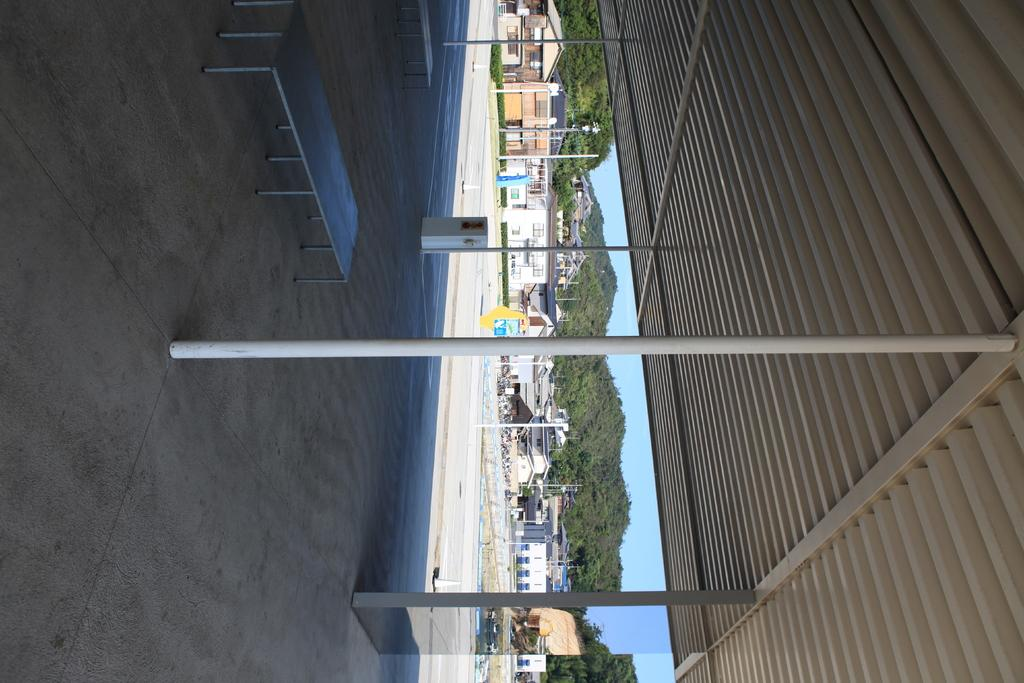What structure is located on the right side of the image? There is a shed on the right side of the image. What can be seen in the center of the image? There is a pole and a bench in the center of the image. What type of structures can be seen in the background of the image? There are houses and poles in the background of the image. What natural feature might be visible in the background of the image? It appears there are mountains in the background of the image. What is visible in the background of the image? The sky is visible in the background of the image. What type of metal is used to construct the mailbox in the image? There is no mailbox present in the image. How much dirt can be seen on the bench in the image? There is no dirt visible on the bench in the image. 